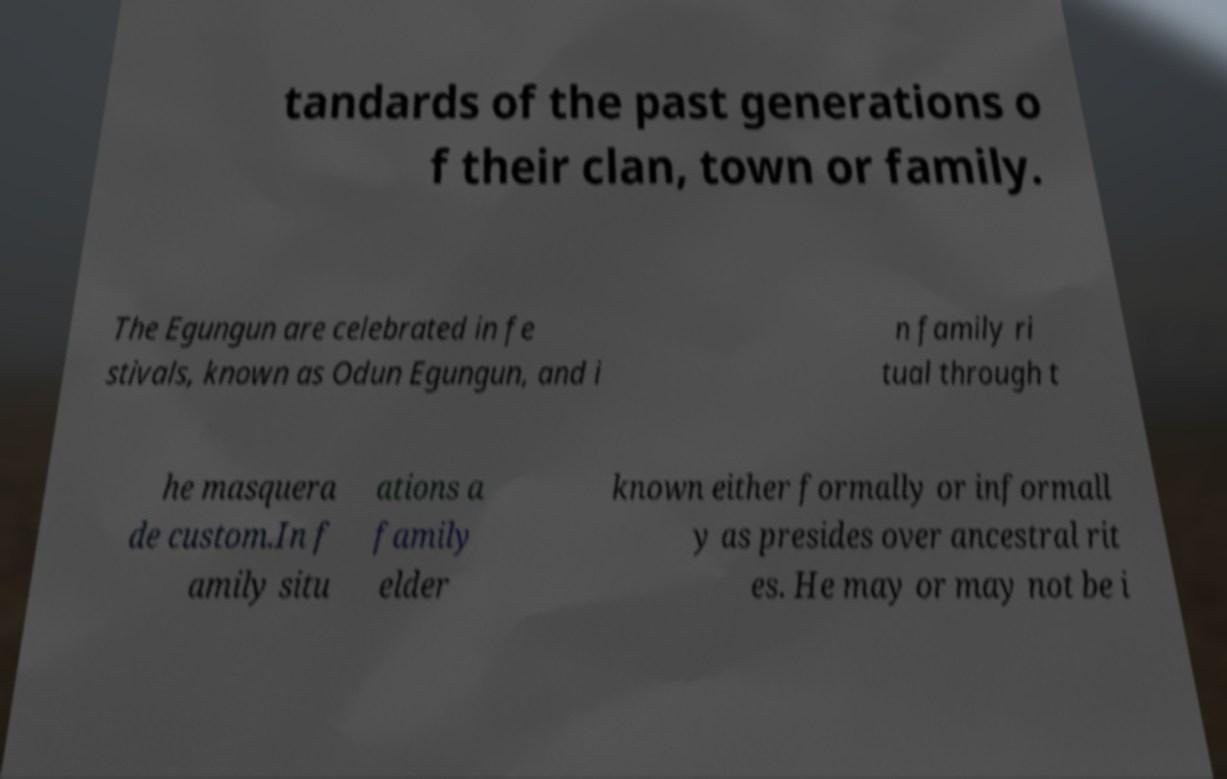Please identify and transcribe the text found in this image. tandards of the past generations o f their clan, town or family. The Egungun are celebrated in fe stivals, known as Odun Egungun, and i n family ri tual through t he masquera de custom.In f amily situ ations a family elder known either formally or informall y as presides over ancestral rit es. He may or may not be i 